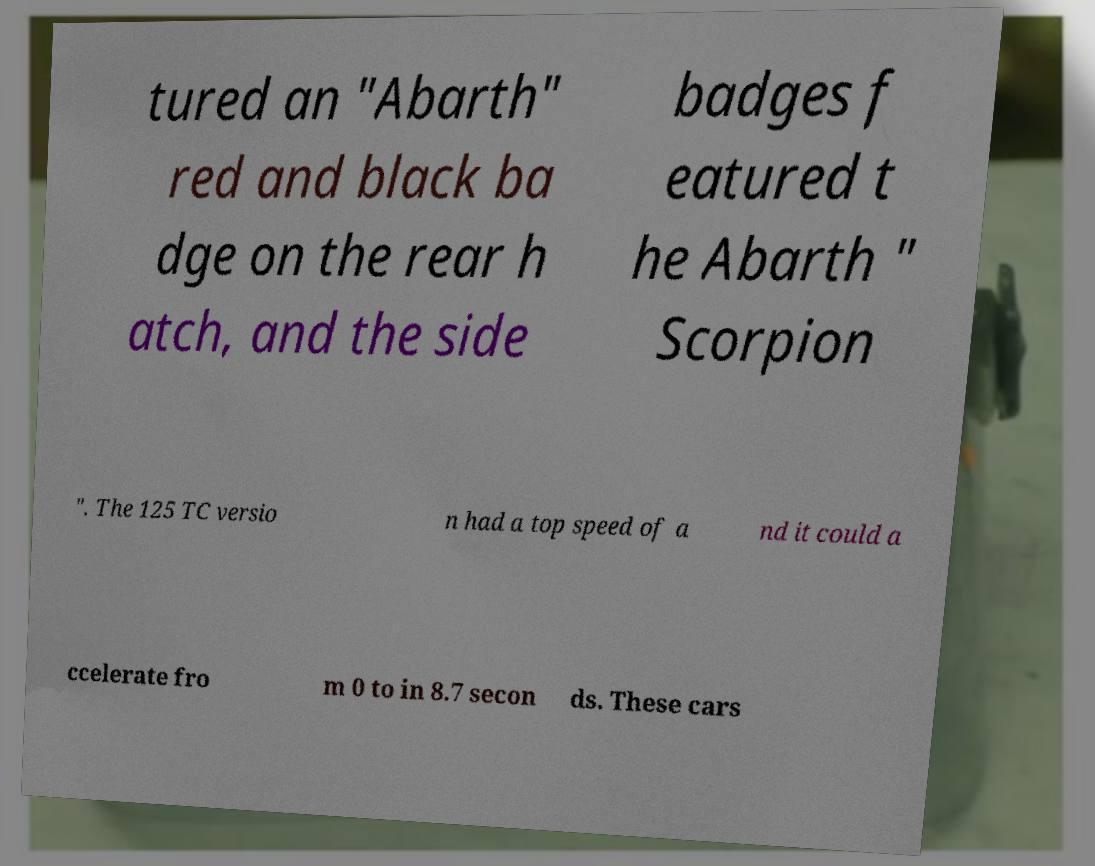What messages or text are displayed in this image? I need them in a readable, typed format. tured an "Abarth" red and black ba dge on the rear h atch, and the side badges f eatured t he Abarth " Scorpion ". The 125 TC versio n had a top speed of a nd it could a ccelerate fro m 0 to in 8.7 secon ds. These cars 